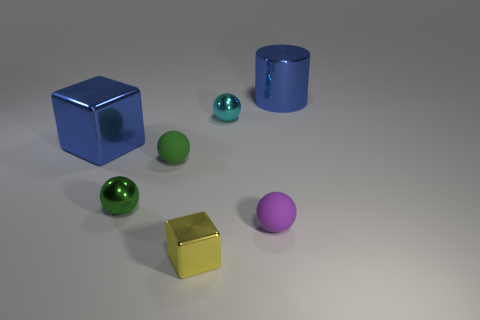There is a shiny thing that is the same color as the big metallic cube; what is its shape?
Make the answer very short. Cylinder. How many other things have the same size as the yellow metal thing?
Give a very brief answer. 4. What is the color of the thing that is both on the right side of the tiny cyan object and behind the tiny green metallic thing?
Keep it short and to the point. Blue. What number of objects are tiny brown shiny spheres or small objects?
Make the answer very short. 5. What number of big things are things or purple rubber spheres?
Offer a terse response. 2. Is there any other thing that has the same color as the big metal cylinder?
Your answer should be very brief. Yes. There is a ball that is both behind the small green metal thing and on the right side of the yellow thing; what size is it?
Provide a short and direct response. Small. Do the rubber sphere to the left of the cyan shiny ball and the small metallic sphere in front of the cyan metal ball have the same color?
Ensure brevity in your answer.  Yes. How many other things are there of the same material as the yellow object?
Give a very brief answer. 4. There is a object that is both on the right side of the small cyan thing and in front of the large blue cylinder; what is its shape?
Keep it short and to the point. Sphere. 